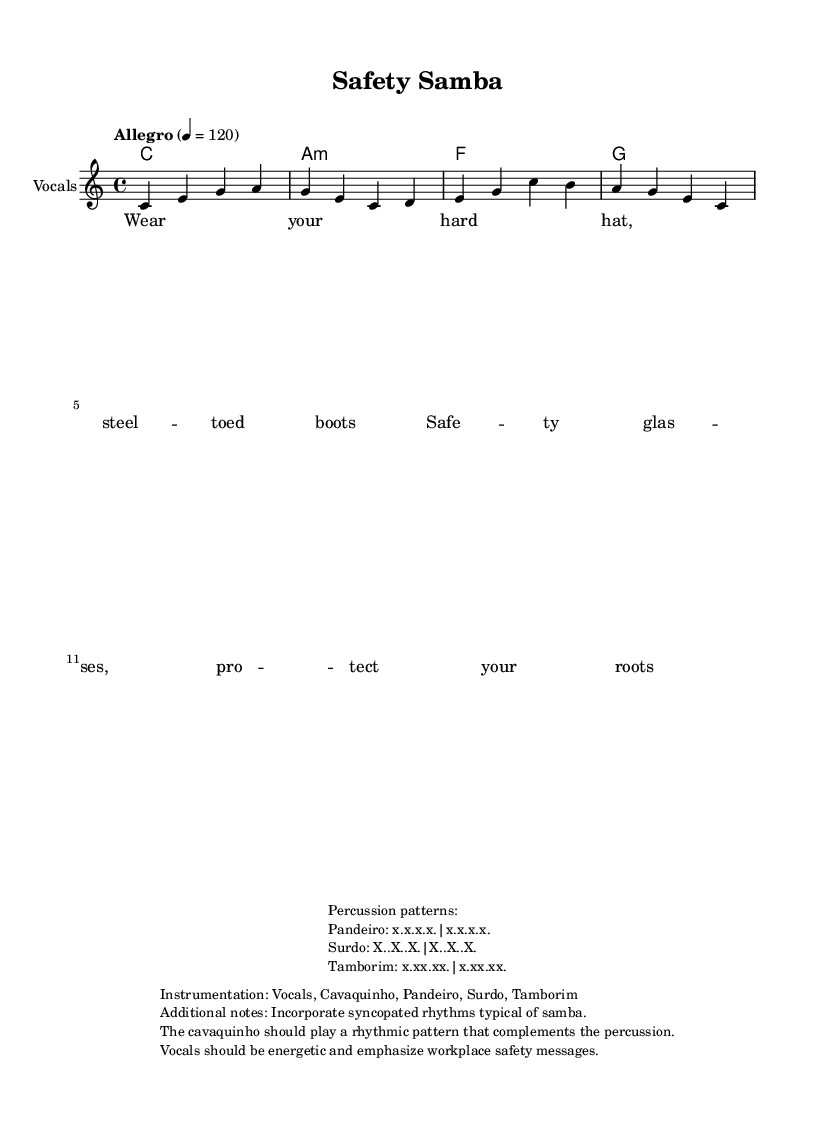What is the key signature of this music? The key signature is indicated at the beginning of the score. It shows no sharps or flats, which corresponds to C major.
Answer: C major What is the time signature of the piece? The time signature is presented at the start of the sheet music, showing a "4/4" signature, which means there are four beats per measure.
Answer: 4/4 What is the tempo marking for this piece? The tempo marking is written at the top of the score and specifies "Allegro," meaning it should be played at a lively tempo; the number 4 = 120 indicates the beats per minute.
Answer: Allegro, 120 How many measures are in the melody section? The melody section is comprised of eight measures, as broken down by the vertical barlines that separate the groups of notes.
Answer: Eight What instruments are included in the instrumentation? The instrumentation is mentioned in the markup section of the sheet music, listing the various instruments used, which are highlighted in the description provided.
Answer: Vocals, Cavaquinho, Pandeiro, Surdo, Tamborim What message does the lyrics convey in the song? The lyrics emphasize the importance of wearing safety equipment while working, using common safety gear as examples to promote workplace safety.
Answer: Workplace safety 